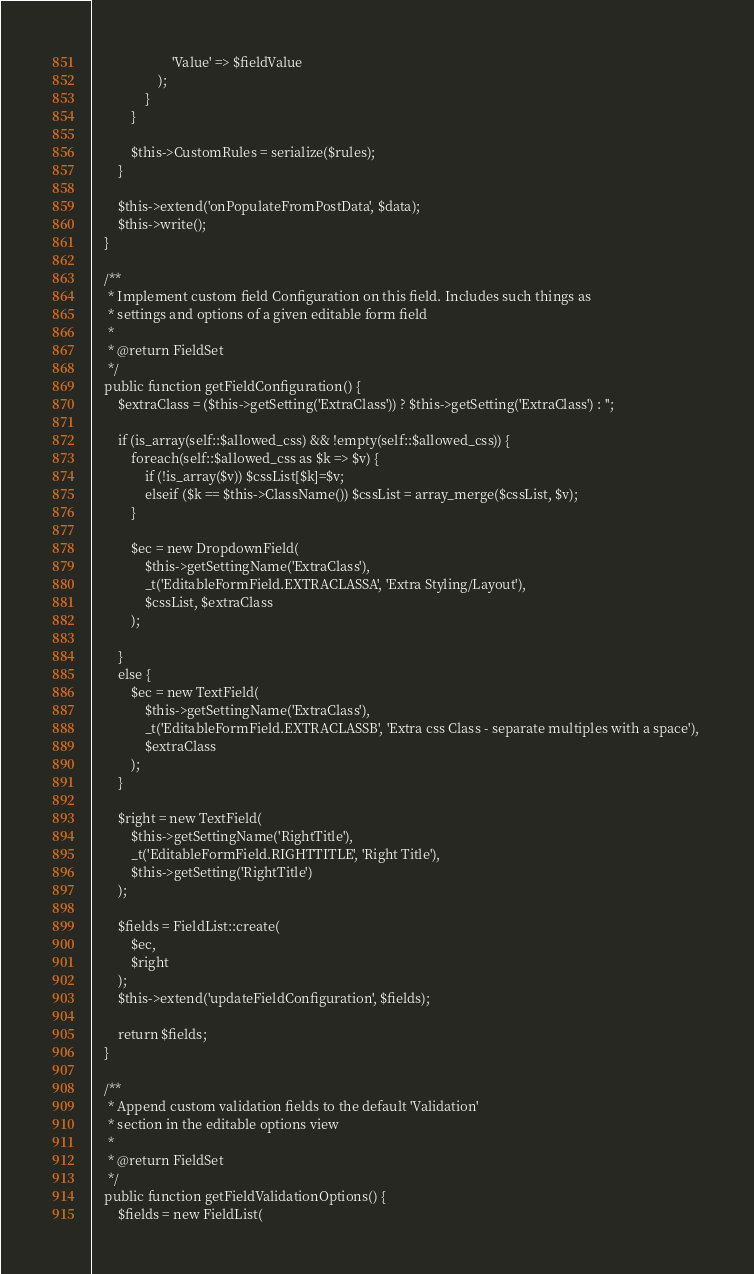<code> <loc_0><loc_0><loc_500><loc_500><_PHP_>						'Value' => $fieldValue
					);
				}
			}
			
			$this->CustomRules = serialize($rules);
		}

		$this->extend('onPopulateFromPostData', $data);
		$this->write();
	}
	 
	/**
	 * Implement custom field Configuration on this field. Includes such things as
	 * settings and options of a given editable form field
	 *
	 * @return FieldSet
	 */
	public function getFieldConfiguration() {
		$extraClass = ($this->getSetting('ExtraClass')) ? $this->getSetting('ExtraClass') : '';

		if (is_array(self::$allowed_css) && !empty(self::$allowed_css)) {
			foreach(self::$allowed_css as $k => $v) {
				if (!is_array($v)) $cssList[$k]=$v;
				elseif ($k == $this->ClassName()) $cssList = array_merge($cssList, $v);
			}
			
			$ec = new DropdownField(
				$this->getSettingName('ExtraClass'), 
				_t('EditableFormField.EXTRACLASSA', 'Extra Styling/Layout'), 
				$cssList, $extraClass
			);
			
		}
		else {
			$ec = new TextField(
				$this->getSettingName('ExtraClass'), 
				_t('EditableFormField.EXTRACLASSB', 'Extra css Class - separate multiples with a space'), 
				$extraClass
			);
		}
		
		$right = new TextField(
			$this->getSettingName('RightTitle'), 
			_t('EditableFormField.RIGHTTITLE', 'Right Title'), 
			$this->getSetting('RightTitle')
		);

        $fields = FieldList::create(
            $ec,
            $right
        );
        $this->extend('updateFieldConfiguration', $fields);
        
        return $fields;
	}
	
	/**
	 * Append custom validation fields to the default 'Validation' 
	 * section in the editable options view
	 * 
	 * @return FieldSet
	 */
	public function getFieldValidationOptions() {
		$fields = new FieldList(</code> 